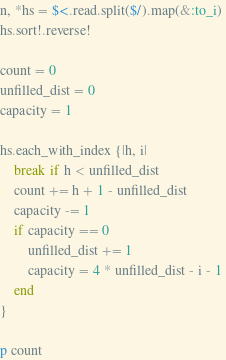<code> <loc_0><loc_0><loc_500><loc_500><_Ruby_>n, *hs = $<.read.split($/).map(&:to_i)
hs.sort!.reverse!

count = 0 
unfilled_dist = 0 
capacity = 1 

hs.each_with_index {|h, i|
    break if h < unfilled_dist
    count += h + 1 - unfilled_dist
    capacity -= 1
    if capacity == 0
        unfilled_dist += 1
        capacity = 4 * unfilled_dist - i - 1 
    end 
}

p count</code> 